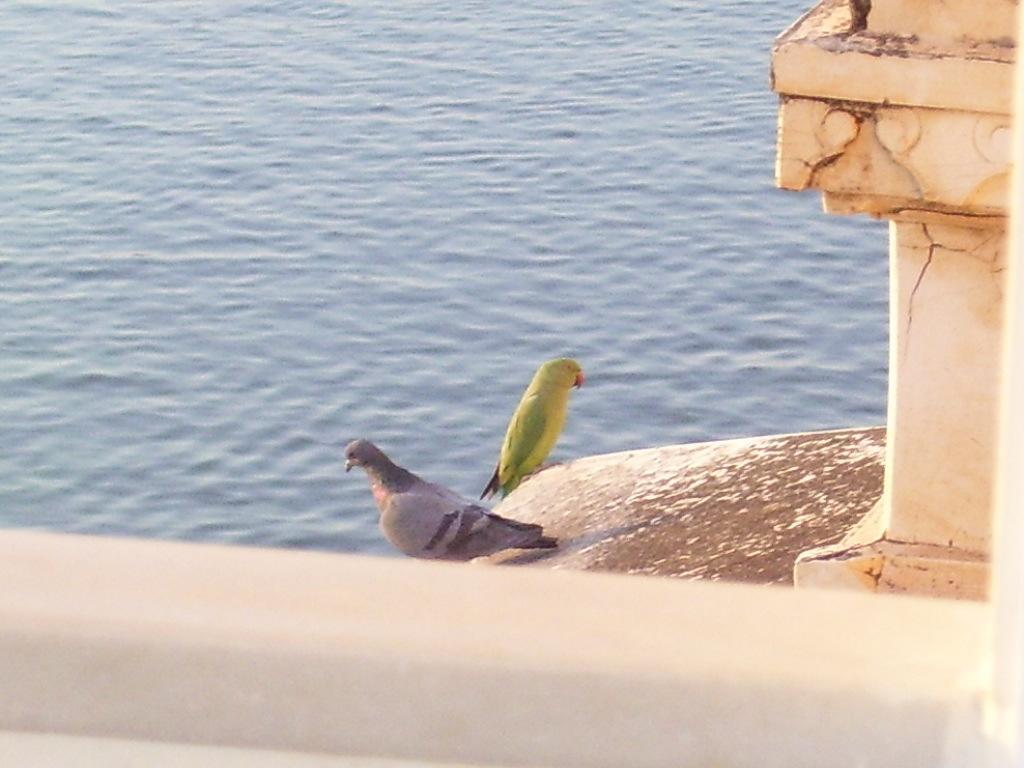Could you give a brief overview of what you see in this image? There is a parrot and a pigeon in the foreground area of the image, it seems like a pillar on the right and a wall at the bottom side. There is water in the background. 